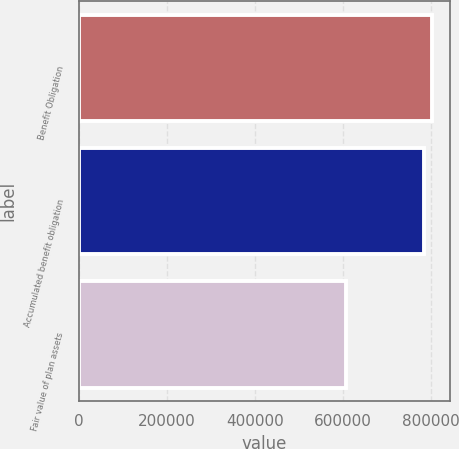<chart> <loc_0><loc_0><loc_500><loc_500><bar_chart><fcel>Benefit Obligation<fcel>Accumulated benefit obligation<fcel>Fair value of plan assets<nl><fcel>803812<fcel>784337<fcel>607705<nl></chart> 